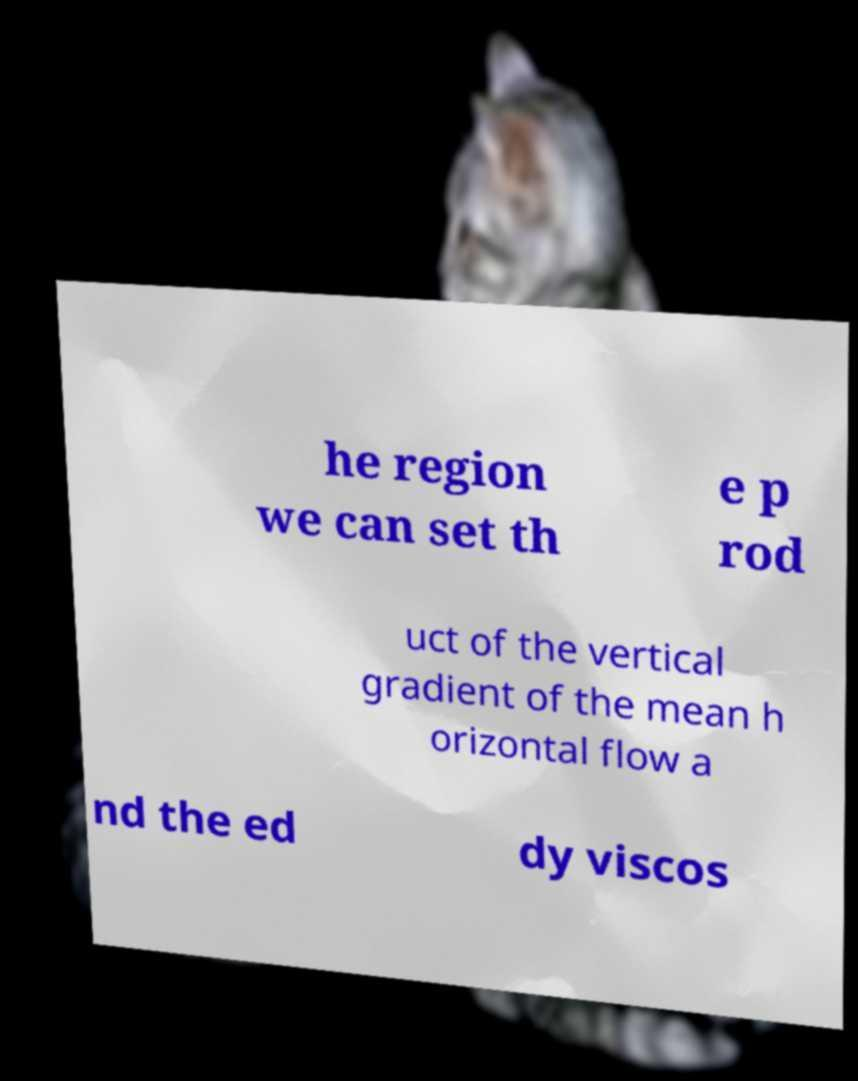What messages or text are displayed in this image? I need them in a readable, typed format. he region we can set th e p rod uct of the vertical gradient of the mean h orizontal flow a nd the ed dy viscos 